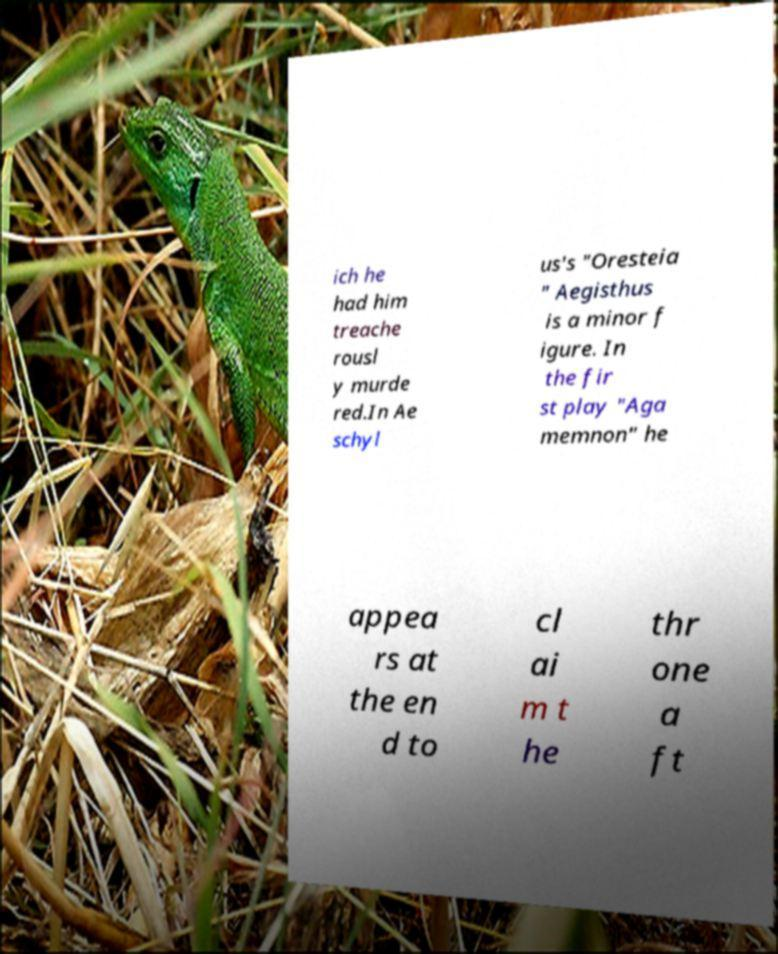Can you read and provide the text displayed in the image?This photo seems to have some interesting text. Can you extract and type it out for me? ich he had him treache rousl y murde red.In Ae schyl us's "Oresteia " Aegisthus is a minor f igure. In the fir st play "Aga memnon" he appea rs at the en d to cl ai m t he thr one a ft 